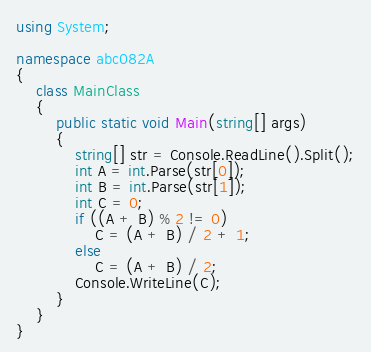<code> <loc_0><loc_0><loc_500><loc_500><_C#_>using System;

namespace abc082A
{
    class MainClass
    {
        public static void Main(string[] args)
        {
            string[] str = Console.ReadLine().Split();
            int A = int.Parse(str[0]);
            int B = int.Parse(str[1]);
            int C = 0;
            if ((A + B) % 2 != 0)
                C = (A + B) / 2 + 1;
            else
                C = (A + B) / 2;
            Console.WriteLine(C);
        }
    }
}
</code> 